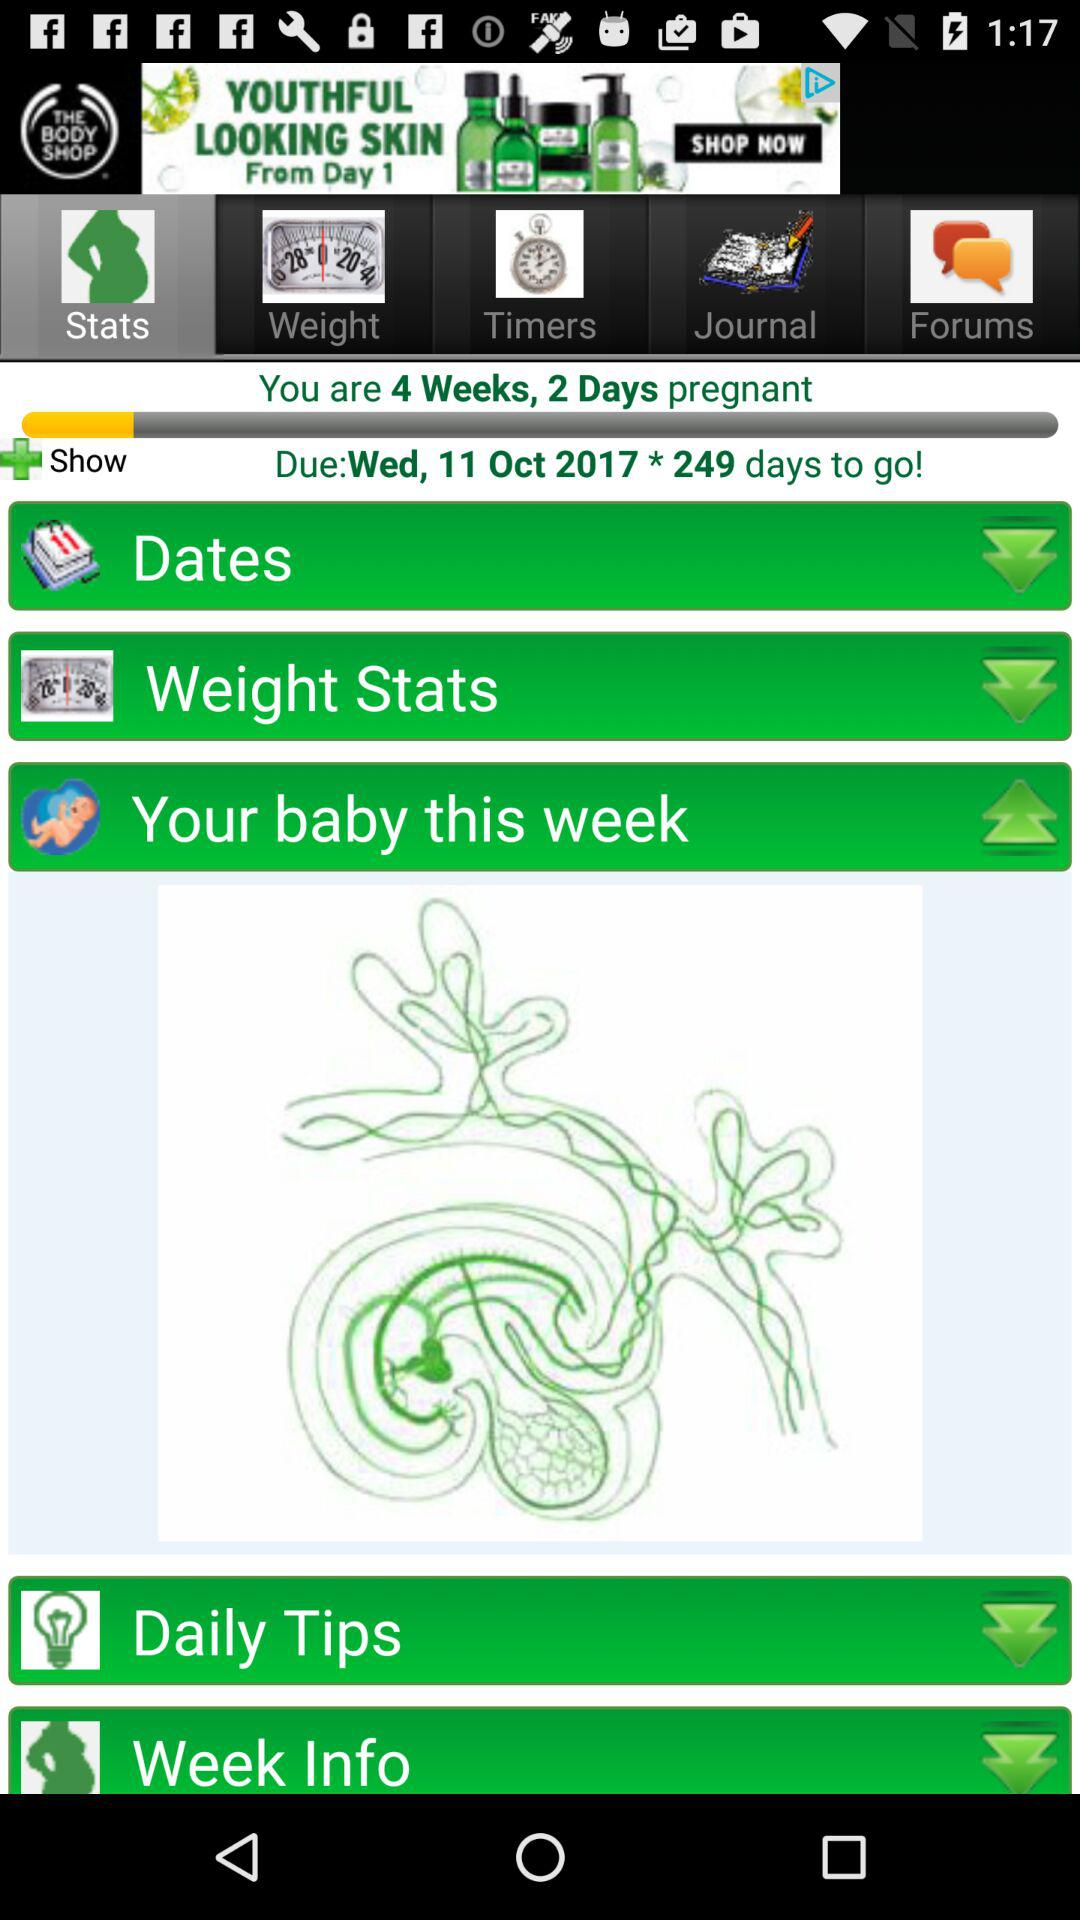How much weight has been gained since week 1?
When the provided information is insufficient, respond with <no answer>. <no answer> 